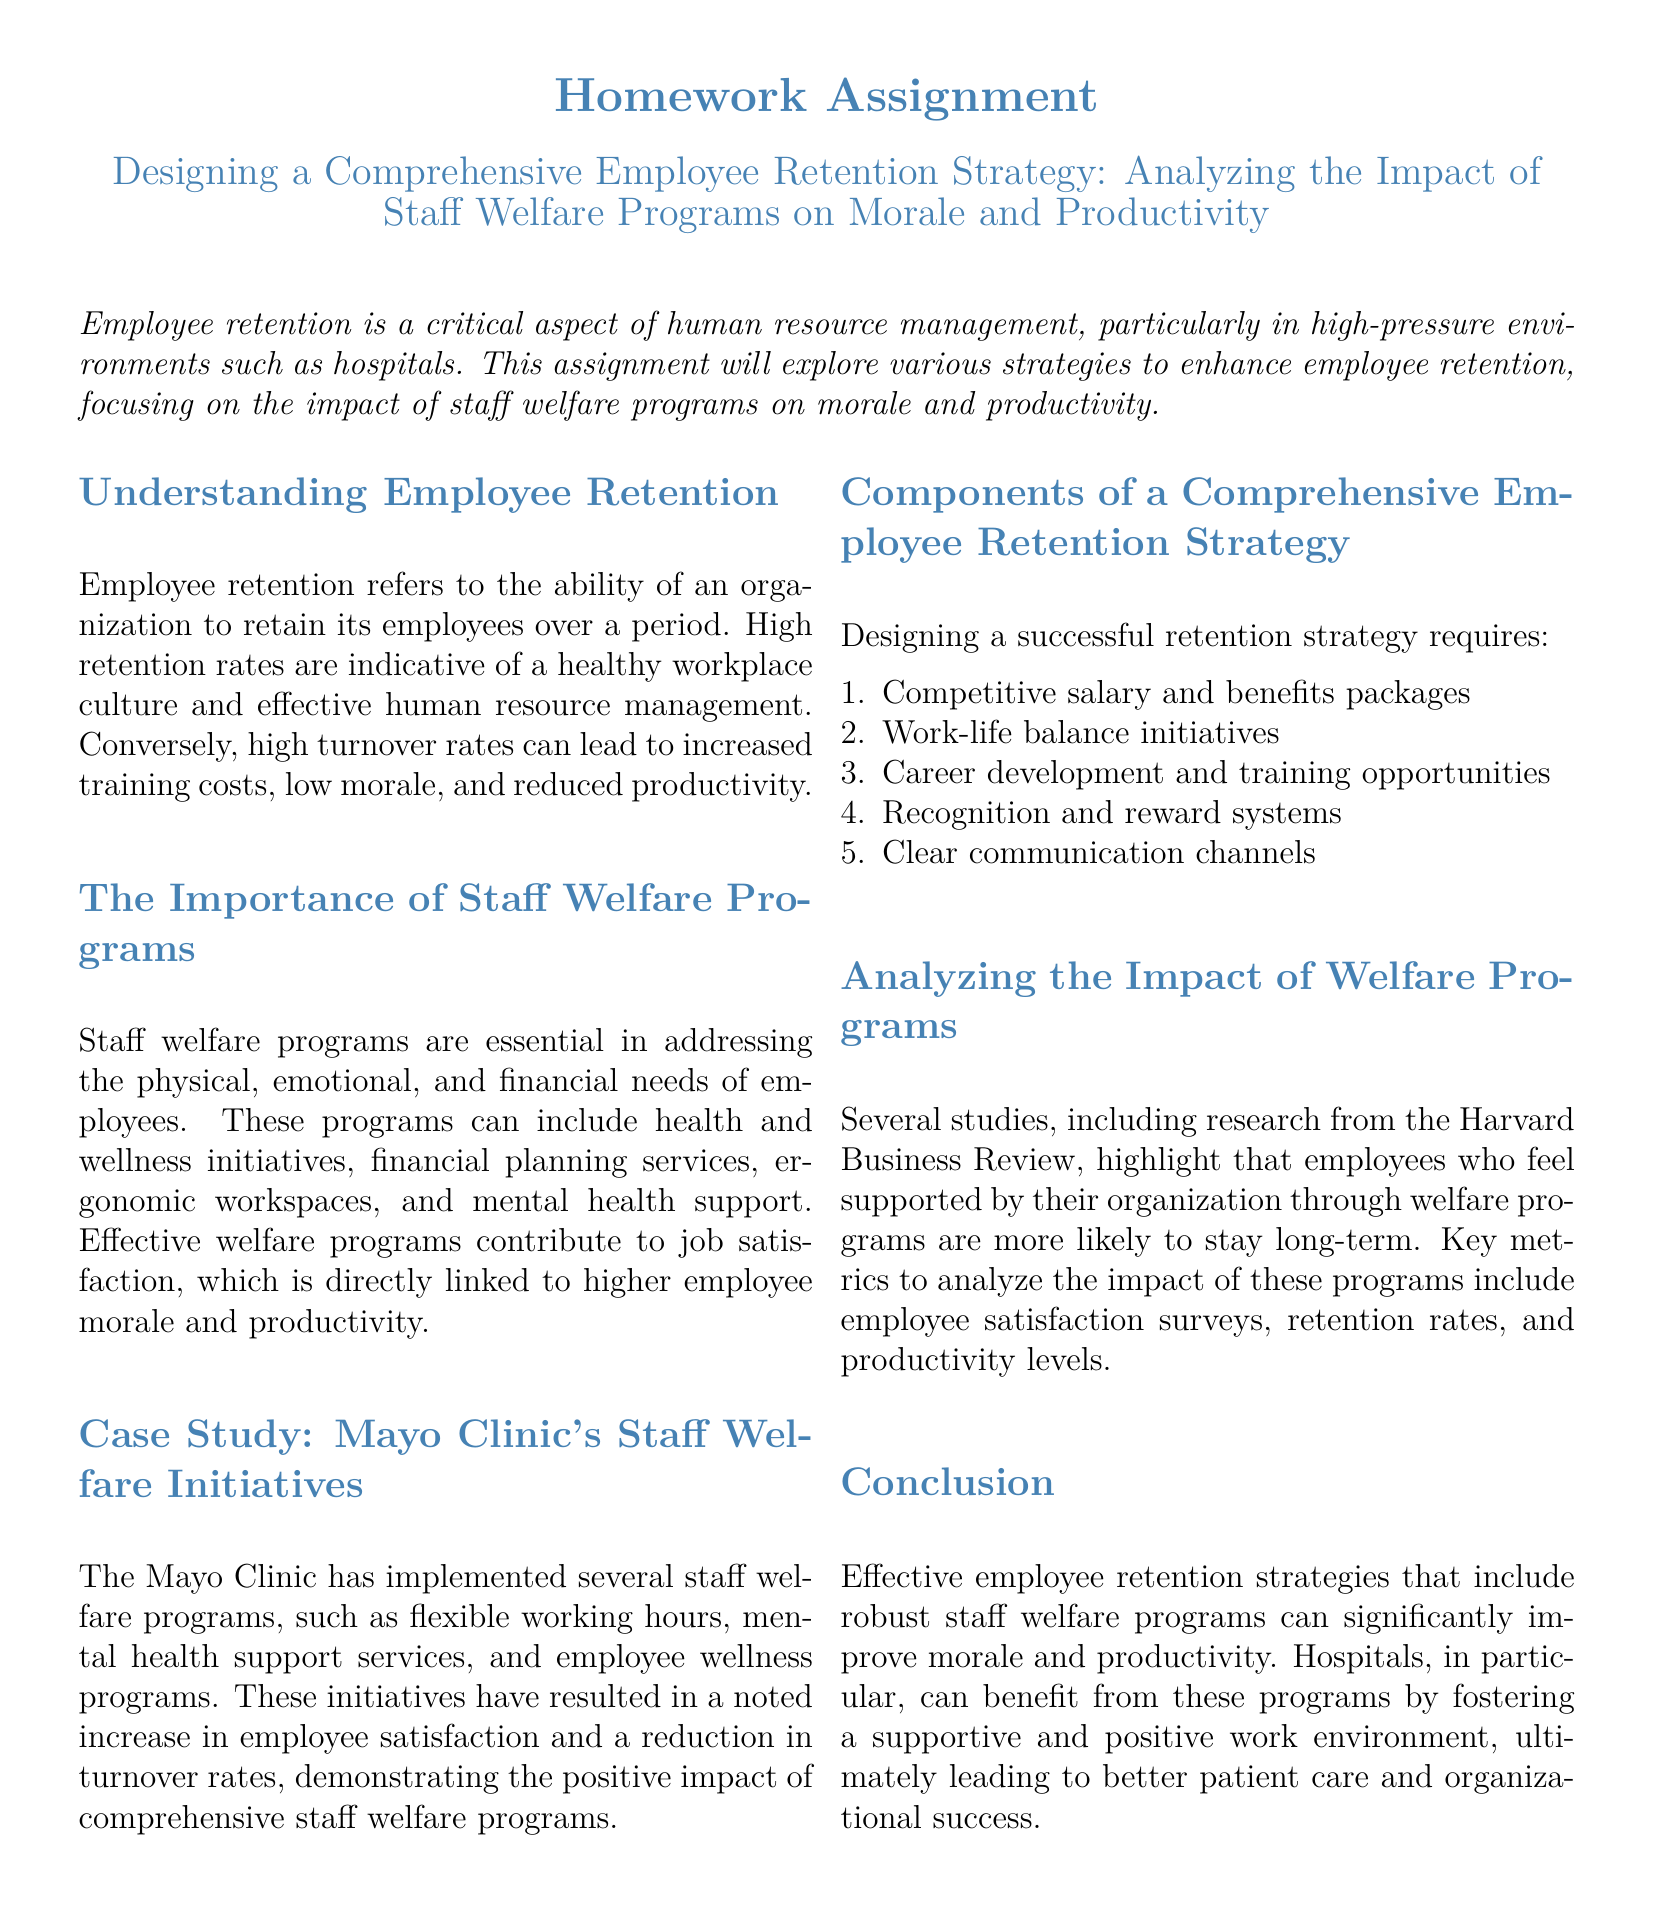what is the title of the homework assignment? The title is provided in the document's header.
Answer: Designing a Comprehensive Employee Retention Strategy: Analyzing the Impact of Staff Welfare Programs on Morale and Productivity what does employee retention refer to? The document defines employee retention in the context of organizational ability.
Answer: The ability of an organization to retain its employees over a period which prestigious hospital is mentioned as a case study in the document? The document presents a specific hospital known for its employee welfare initiatives.
Answer: Mayo Clinic name one type of initiative included in staff welfare programs. The document lists several initiatives under staff welfare programs.
Answer: Health and wellness initiatives how many components are listed in the employee retention strategy? The document enumerates the components of the strategy under a numbered list.
Answer: Five what is the relationship between job satisfaction and employee morale according to the document? The document states a direct link between two concepts.
Answer: Directly linked which two metrics are suggested for analyzing the impact of welfare programs? The document emphasizes specific metrics to evaluate the effectiveness of programs.
Answer: Employee satisfaction surveys and retention rates what is one outcome of the Mayo Clinic's staff welfare programs according to the case study? The case study provides evidence of an improvement due to specific initiatives.
Answer: Increase in employee satisfaction what is the primary benefit of effective employee retention strategies as mentioned in the conclusion? The document concludes with the overarching benefit of implementation.
Answer: Improve morale and productivity 